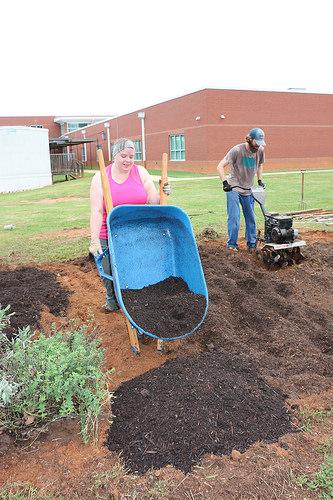<image>
Is the dirt under the lady? No. The dirt is not positioned under the lady. The vertical relationship between these objects is different. Is there a wheelbarrow to the right of the dirt? No. The wheelbarrow is not to the right of the dirt. The horizontal positioning shows a different relationship. 